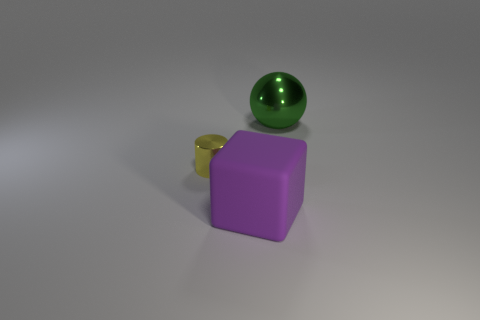Add 1 big yellow rubber spheres. How many objects exist? 4 Subtract all balls. How many objects are left? 2 Add 1 brown metallic cubes. How many brown metallic cubes exist? 1 Subtract 0 yellow spheres. How many objects are left? 3 Subtract all small cylinders. Subtract all tiny objects. How many objects are left? 1 Add 1 rubber objects. How many rubber objects are left? 2 